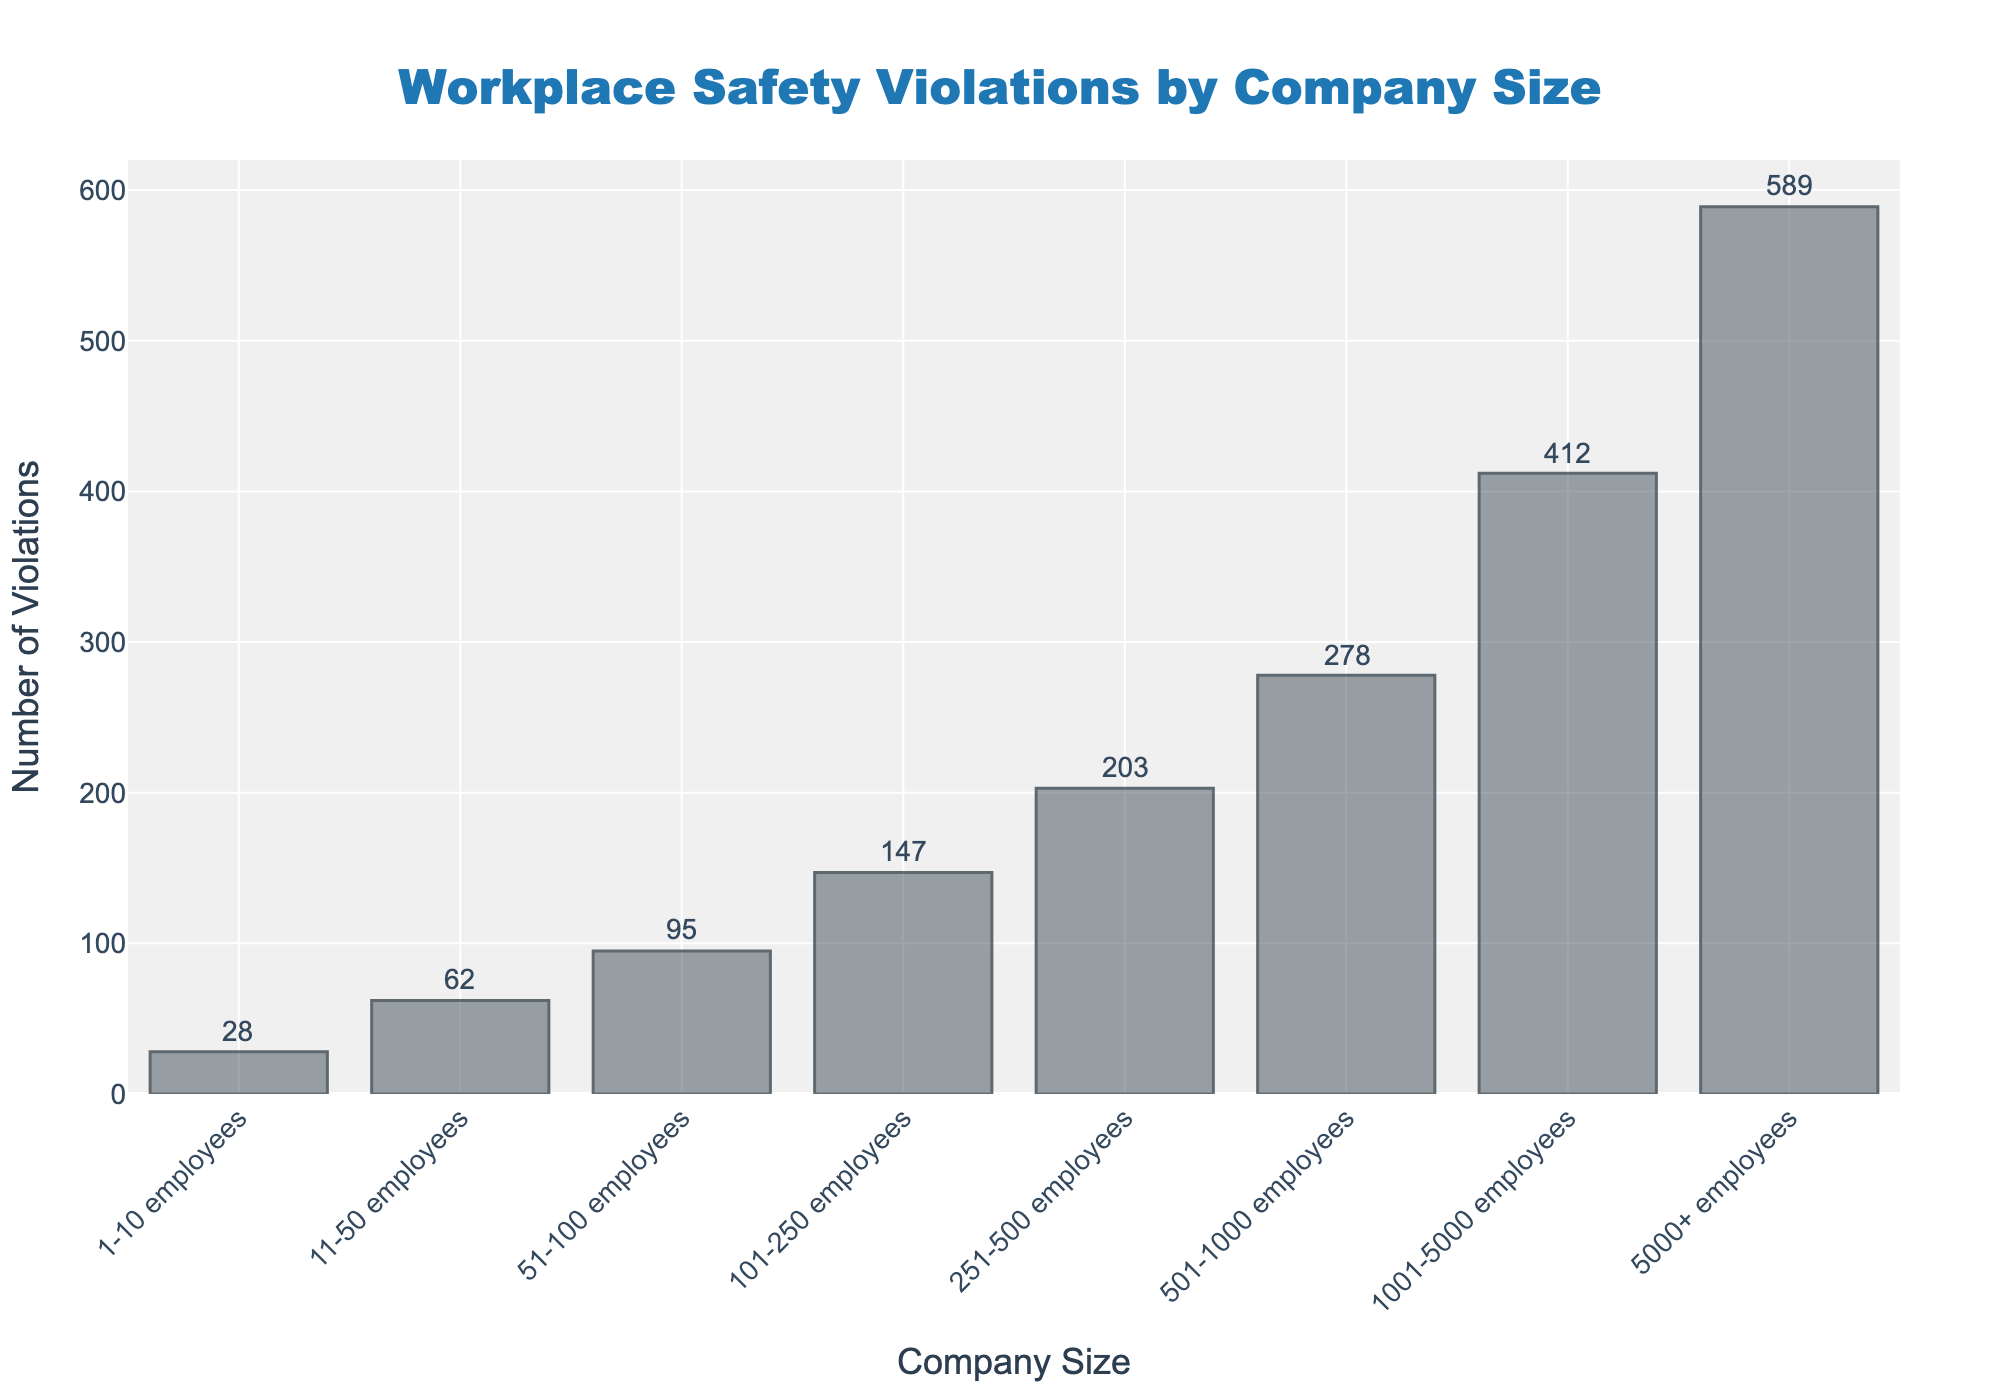What is the title of the figure? The title of the figure is displayed at the top and reads "Workplace Safety Violations by Company Size."
Answer: Workplace Safety Violations by Company Size How many company size categories are shown in the figure? The figure includes a bar for each company size category. By counting the bars or the X-axis labels, we can see that there are eight company size categories.
Answer: Eight What is the number of violations for the company size category "101-250 employees"? The bar corresponding to "101-250 employees" reaches up to 147 violations, which is labeled on the figure.
Answer: 147 Which company size category has the highest number of violations? Comparing the heights of all the bars visually or the annotations, the bar for "5000+ employees" is the tallest, indicating the highest number of violations.
Answer: 5000+ employees How much higher is the number of violations for "1001-5000 employees" compared to "101-250 employees"? According to the labels, "1001-5000 employees" has 412 violations, and "101-250 employees" has 147 violations. The difference is 412 - 147 = 265.
Answer: 265 What's the average number of violations among all company size categories? Sum the number of violations (28 + 62 + 95 + 147 + 203 + 278 + 412 + 589 = 1814) and divide by the number of categories (8). So, 1814 / 8 = 226.75.
Answer: 226.75 What percentage of total violations are attributed to the "5000+ employees" category? The "5000+ employees" category has 589 violations. Total violations are 1814. The percentage is (589 / 1814) * 100 ≈ 32.47%.
Answer: Approximately 32.47% Which company size categories have fewer than 100 violations? By looking at the bars and their annotations, the categories "1-10 employees," "11-50 employees," and "51-100 employees" have violations less than 100.
Answer: 1-10 employees, 11-50 employees, 51-100 employees Are the bars evenly spaced in the figure? Observing the figure, the bars appear to have regular intervals between them, suggesting even spacing.
Answer: Yes Is there a clear trend in the number of violations as the company size increases? Visually, the bars increase in height as the company size increases, suggesting a trend that larger companies tend to have more violations.
Answer: Yes 